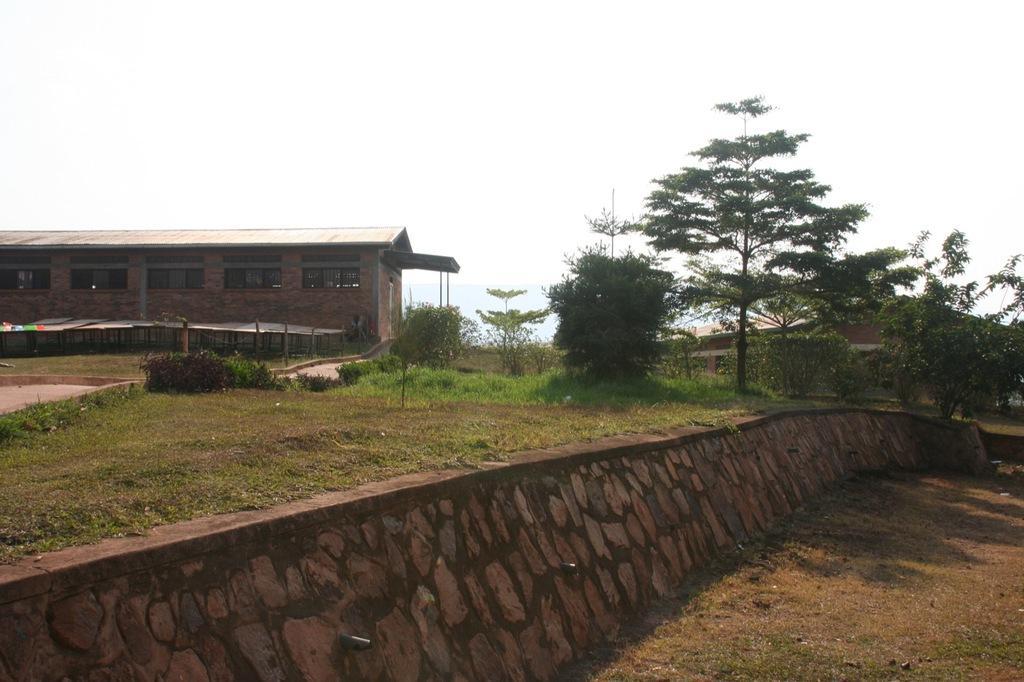Can you describe this image briefly? On the left side, there is a stone wall. Above this wall, there are trees, plants and grass on the ground. On the right side, there is a dry land. In the background, there is a building which is having the roof and windows, there is grass on the ground and there is sky. 